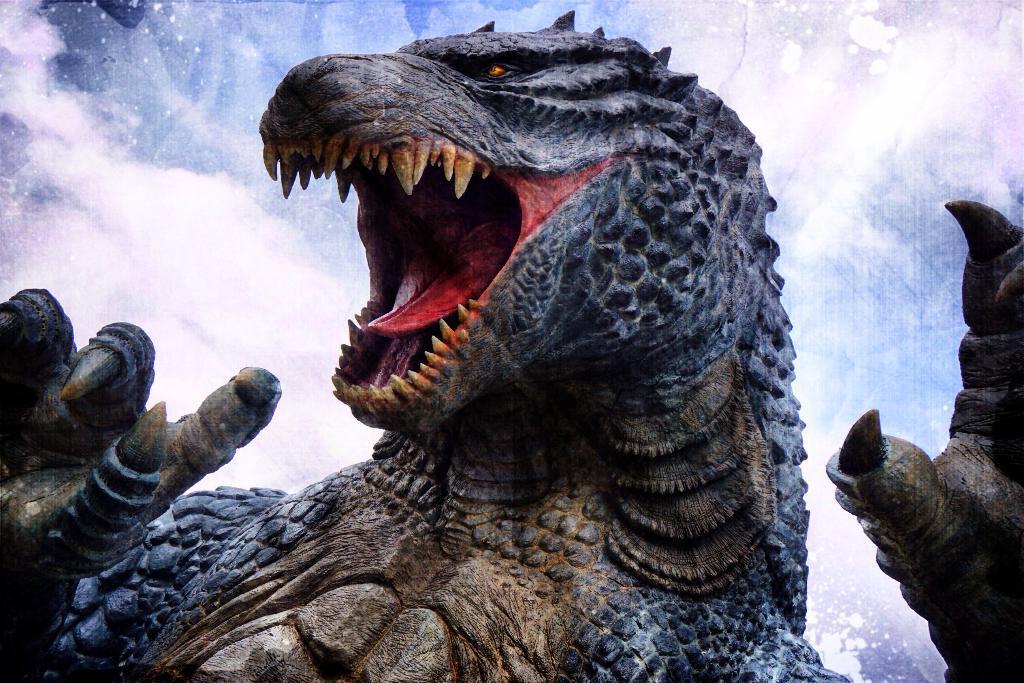Could you give a brief overview of what you see in this image? In this image there is a marine iguana. There are clouds in the sky. 